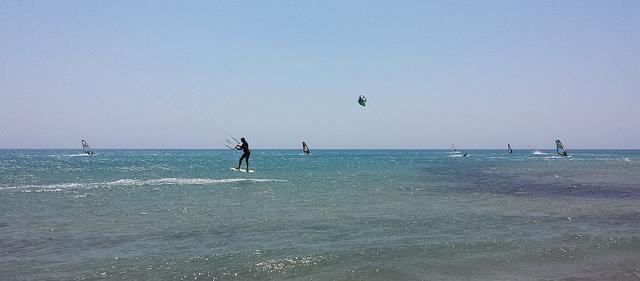How many boats can you make out in the water?
Give a very brief answer. 4. How many people are standing on surfboards?
Give a very brief answer. 1. 